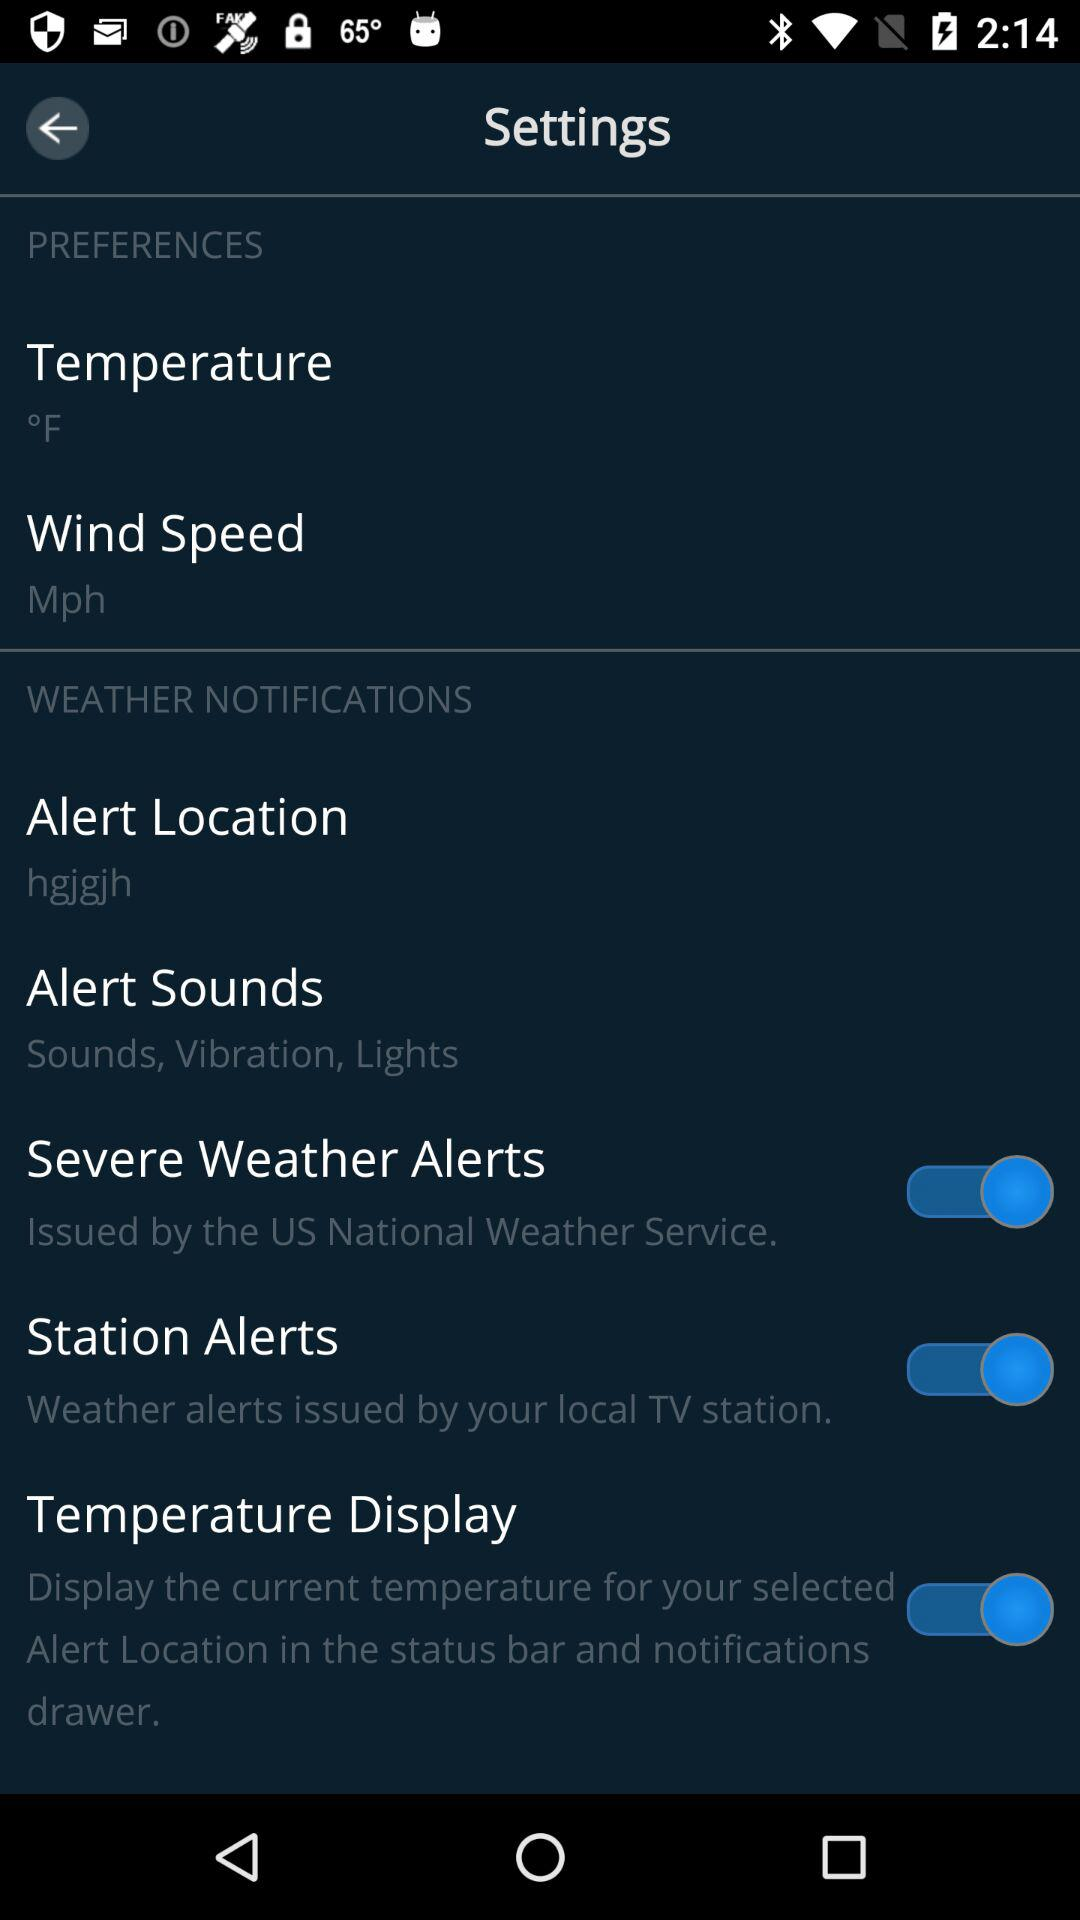What is the unit of wind? The unit is mph. 